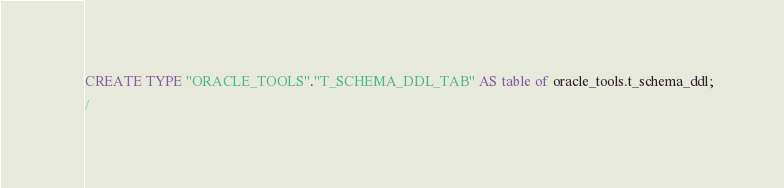Convert code to text. <code><loc_0><loc_0><loc_500><loc_500><_SQL_>CREATE TYPE "ORACLE_TOOLS"."T_SCHEMA_DDL_TAB" AS table of oracle_tools.t_schema_ddl;
/

</code> 